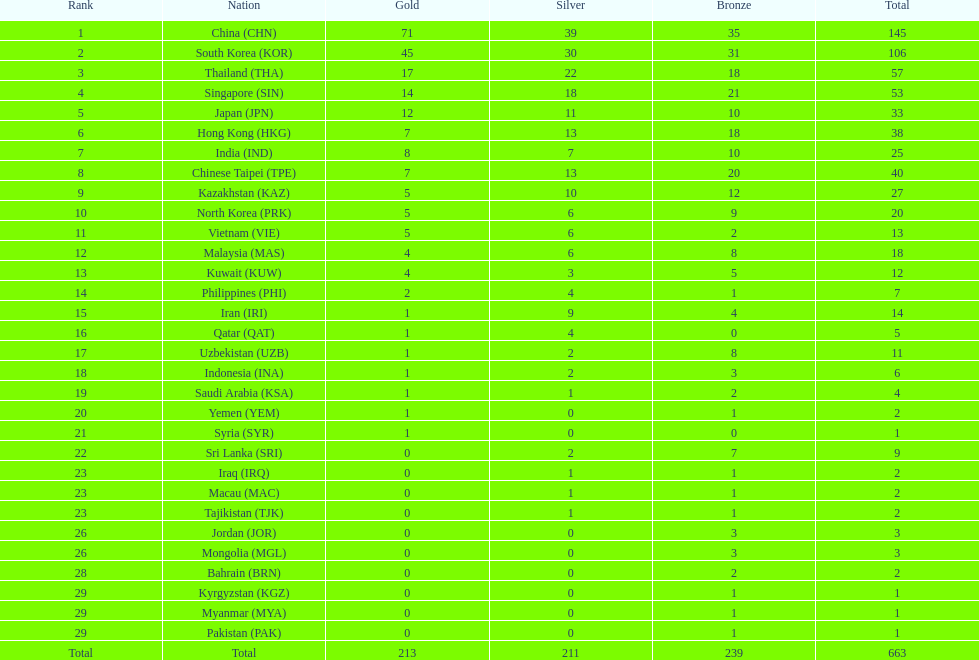What was the total count of medals iran received? 14. 